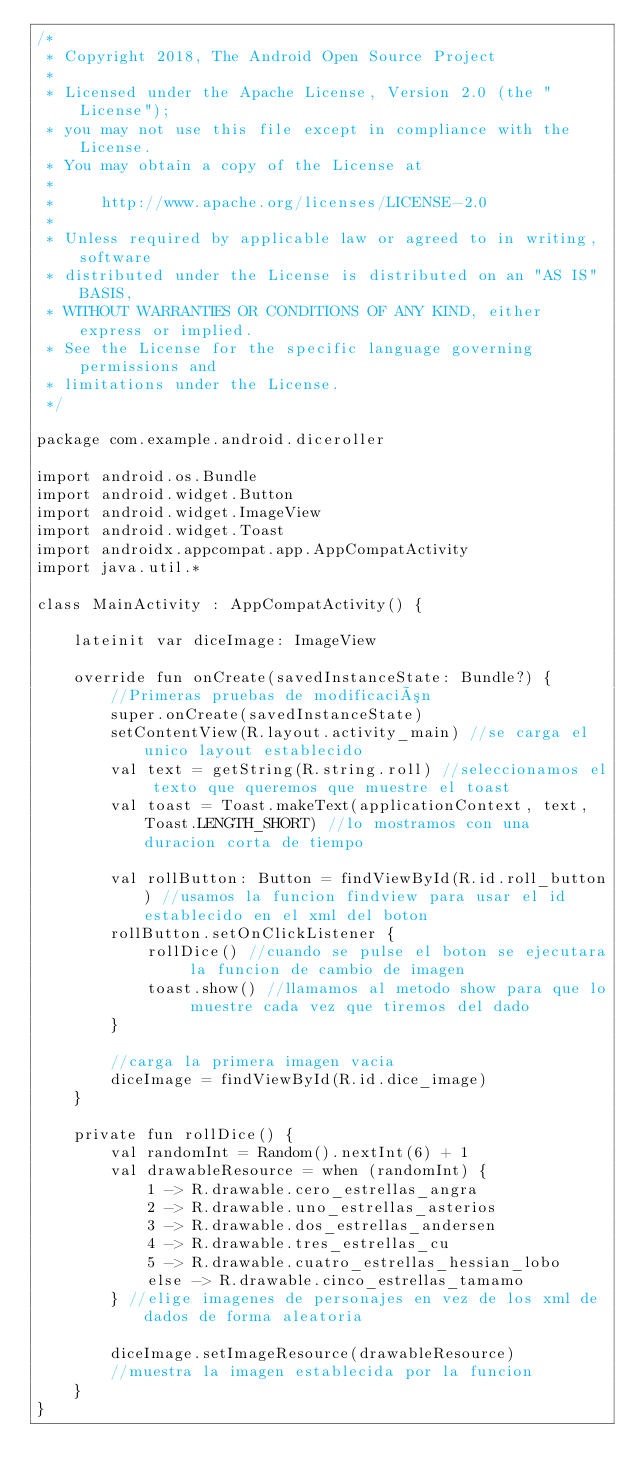<code> <loc_0><loc_0><loc_500><loc_500><_Kotlin_>/*
 * Copyright 2018, The Android Open Source Project
 *
 * Licensed under the Apache License, Version 2.0 (the "License");
 * you may not use this file except in compliance with the License.
 * You may obtain a copy of the License at
 *
 *     http://www.apache.org/licenses/LICENSE-2.0
 *
 * Unless required by applicable law or agreed to in writing, software
 * distributed under the License is distributed on an "AS IS" BASIS,
 * WITHOUT WARRANTIES OR CONDITIONS OF ANY KIND, either express or implied.
 * See the License for the specific language governing permissions and
 * limitations under the License.
 */

package com.example.android.diceroller

import android.os.Bundle
import android.widget.Button
import android.widget.ImageView
import android.widget.Toast
import androidx.appcompat.app.AppCompatActivity
import java.util.*

class MainActivity : AppCompatActivity() {

    lateinit var diceImage: ImageView

    override fun onCreate(savedInstanceState: Bundle?) {
        //Primeras pruebas de modificación
        super.onCreate(savedInstanceState)
        setContentView(R.layout.activity_main) //se carga el unico layout establecido
        val text = getString(R.string.roll) //seleccionamos el texto que queremos que muestre el toast
        val toast = Toast.makeText(applicationContext, text, Toast.LENGTH_SHORT) //lo mostramos con una duracion corta de tiempo

        val rollButton: Button = findViewById(R.id.roll_button) //usamos la funcion findview para usar el id establecido en el xml del boton
        rollButton.setOnClickListener {
            rollDice() //cuando se pulse el boton se ejecutara la funcion de cambio de imagen
            toast.show() //llamamos al metodo show para que lo muestre cada vez que tiremos del dado
        }

        //carga la primera imagen vacia
        diceImage = findViewById(R.id.dice_image)
    }

    private fun rollDice() {
        val randomInt = Random().nextInt(6) + 1
        val drawableResource = when (randomInt) {
            1 -> R.drawable.cero_estrellas_angra
            2 -> R.drawable.uno_estrellas_asterios
            3 -> R.drawable.dos_estrellas_andersen
            4 -> R.drawable.tres_estrellas_cu
            5 -> R.drawable.cuatro_estrellas_hessian_lobo
            else -> R.drawable.cinco_estrellas_tamamo
        } //elige imagenes de personajes en vez de los xml de dados de forma aleatoria

        diceImage.setImageResource(drawableResource)
        //muestra la imagen establecida por la funcion
    }
}
</code> 